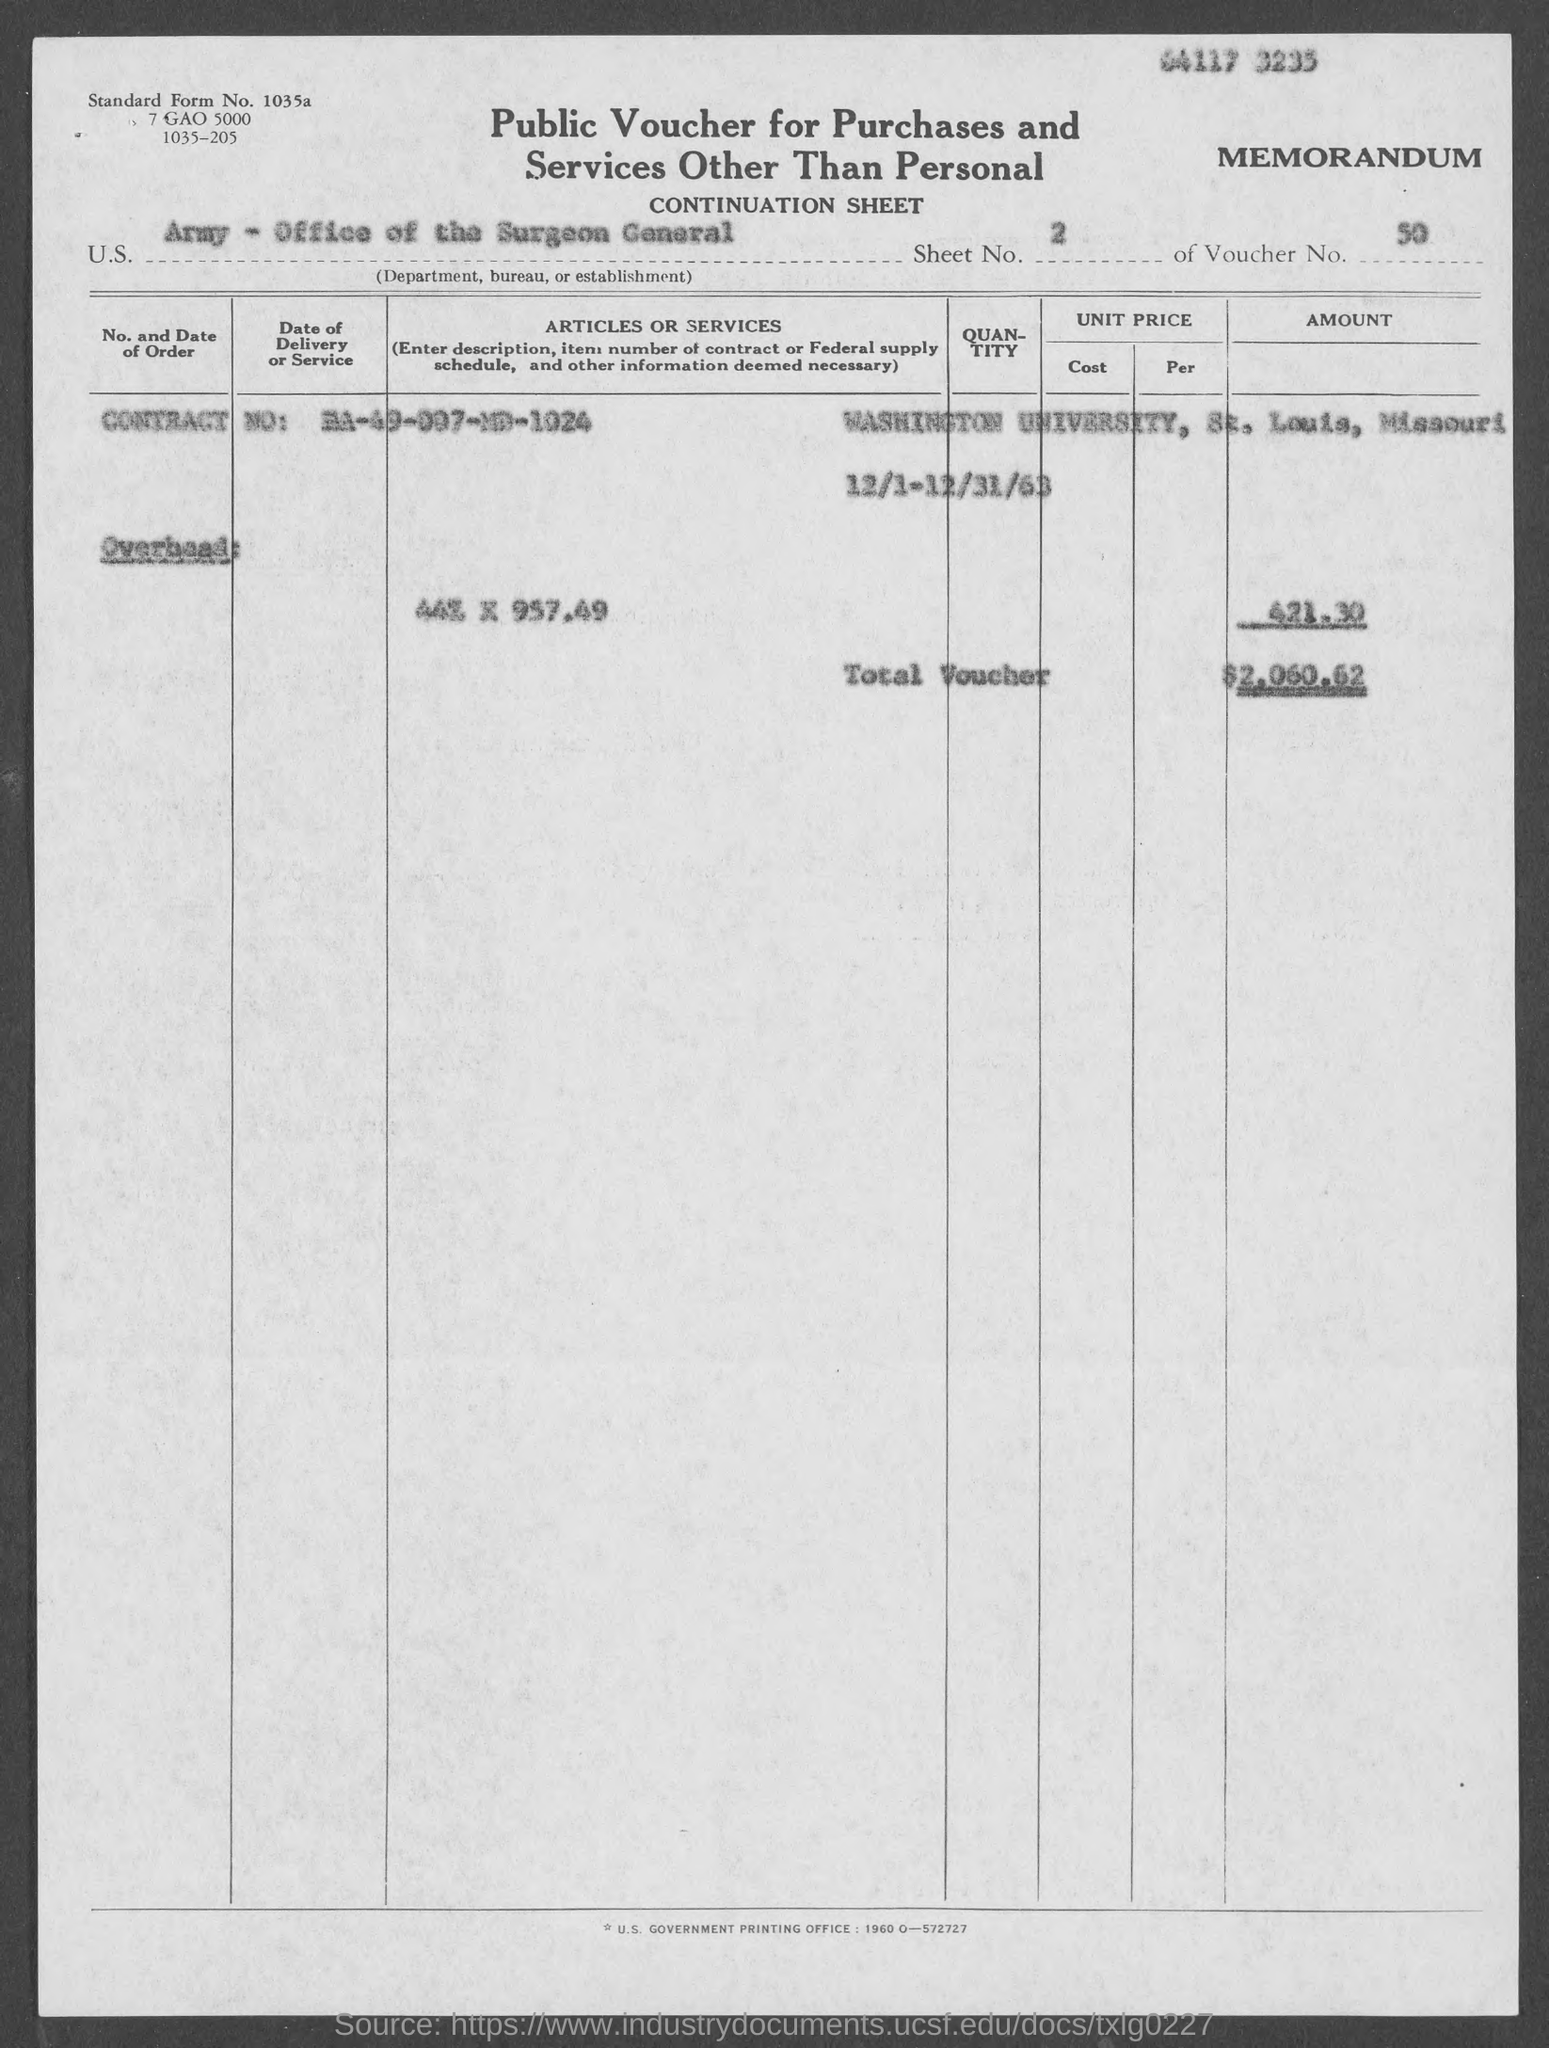Indicate a few pertinent items in this graphic. The standard form number listed in the voucher is 1035a... The Contract No. given in the voucher is DA-49-007-MD-1024. The voucher number provided in the document is 50. The voucher indicates that the U.S. Department, Bureau, or Establishment is the Army - Office of the Surgeon General. The sheet number mentioned in the voucher is 2. 